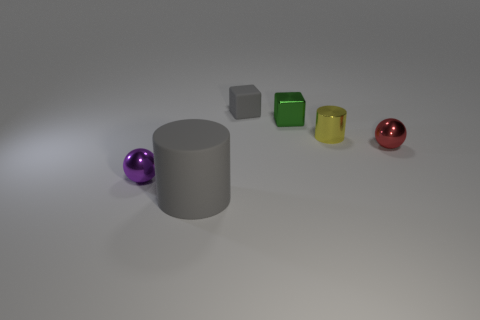Add 2 balls. How many objects exist? 8 Subtract all cubes. How many objects are left? 4 Add 5 tiny cubes. How many tiny cubes are left? 7 Add 2 tiny matte objects. How many tiny matte objects exist? 3 Subtract 0 green spheres. How many objects are left? 6 Subtract all spheres. Subtract all gray rubber cylinders. How many objects are left? 3 